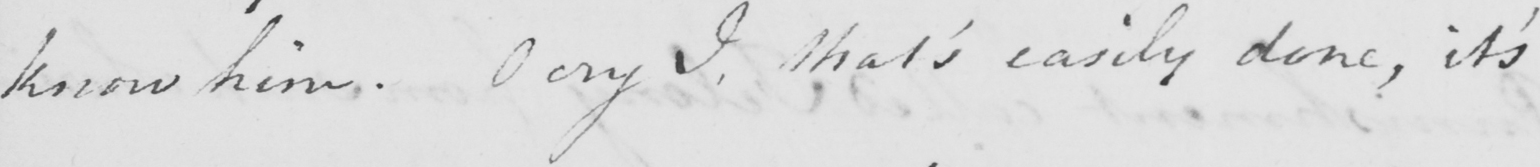Can you read and transcribe this handwriting? know him . O cry I , that ' s easily done , it ' s 